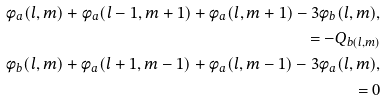<formula> <loc_0><loc_0><loc_500><loc_500>\phi _ { a } ( l , m ) + \phi _ { a } ( l - 1 , m + 1 ) + \phi _ { a } ( l , m + 1 ) - 3 \phi _ { b } ( l , m ) , \\ = - Q _ { b ( l , m ) } \\ \phi _ { b } ( l , m ) + \phi _ { a } ( l + 1 , m - 1 ) + \phi _ { a } ( l , m - 1 ) - 3 \phi _ { a } ( l , m ) , \\ = 0</formula> 